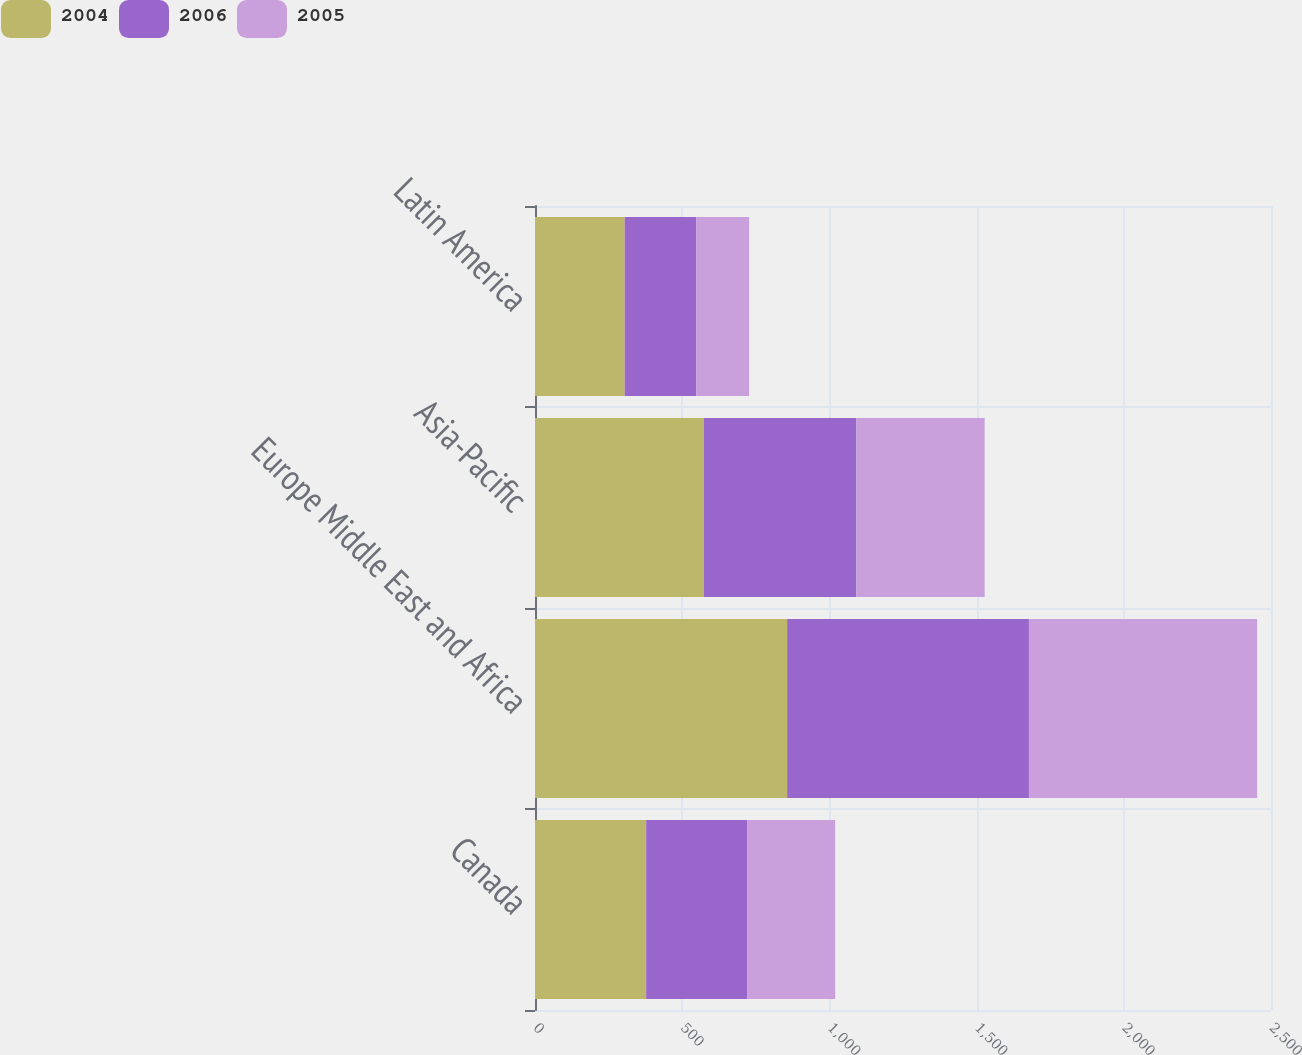Convert chart. <chart><loc_0><loc_0><loc_500><loc_500><stacked_bar_chart><ecel><fcel>Canada<fcel>Europe Middle East and Africa<fcel>Asia-Pacific<fcel>Latin America<nl><fcel>2004<fcel>377.6<fcel>856.5<fcel>573.1<fcel>304.7<nl><fcel>2006<fcel>342.9<fcel>821.3<fcel>518.7<fcel>242.6<nl><fcel>2005<fcel>299.1<fcel>775.1<fcel>435.5<fcel>180.1<nl></chart> 